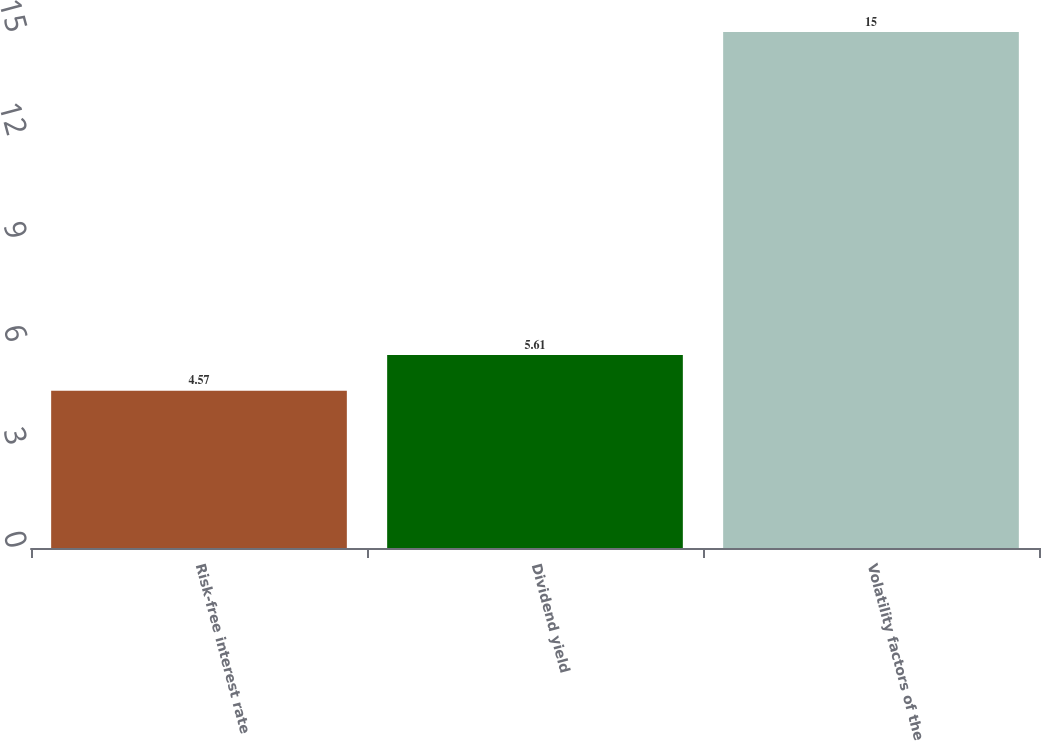Convert chart to OTSL. <chart><loc_0><loc_0><loc_500><loc_500><bar_chart><fcel>Risk-free interest rate<fcel>Dividend yield<fcel>Volatility factors of the<nl><fcel>4.57<fcel>5.61<fcel>15<nl></chart> 